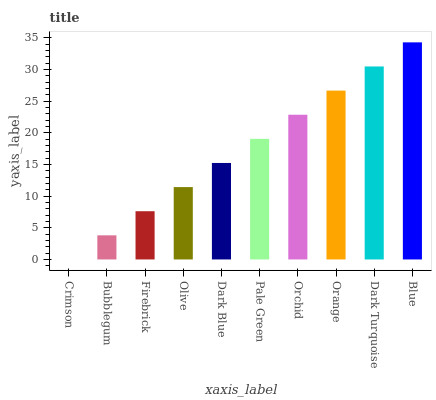Is Bubblegum the minimum?
Answer yes or no. No. Is Bubblegum the maximum?
Answer yes or no. No. Is Bubblegum greater than Crimson?
Answer yes or no. Yes. Is Crimson less than Bubblegum?
Answer yes or no. Yes. Is Crimson greater than Bubblegum?
Answer yes or no. No. Is Bubblegum less than Crimson?
Answer yes or no. No. Is Pale Green the high median?
Answer yes or no. Yes. Is Dark Blue the low median?
Answer yes or no. Yes. Is Firebrick the high median?
Answer yes or no. No. Is Crimson the low median?
Answer yes or no. No. 